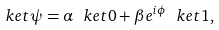Convert formula to latex. <formula><loc_0><loc_0><loc_500><loc_500>\ k e t { \psi } = \alpha \ k e t { 0 } + \beta e ^ { i \phi } \ k e t { 1 } ,</formula> 